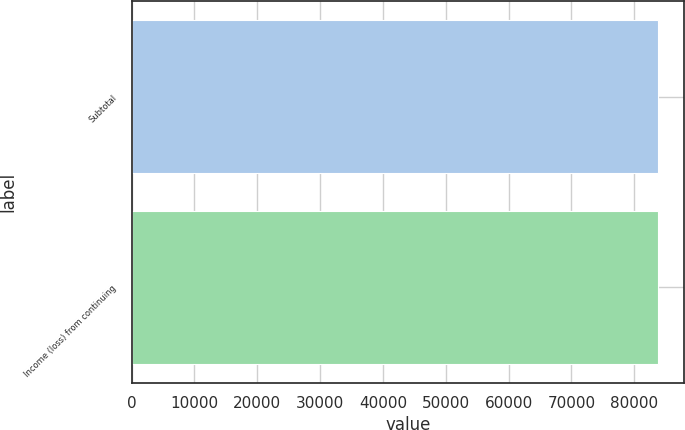Convert chart. <chart><loc_0><loc_0><loc_500><loc_500><bar_chart><fcel>Subtotal<fcel>Income (loss) from continuing<nl><fcel>83758<fcel>83758.1<nl></chart> 